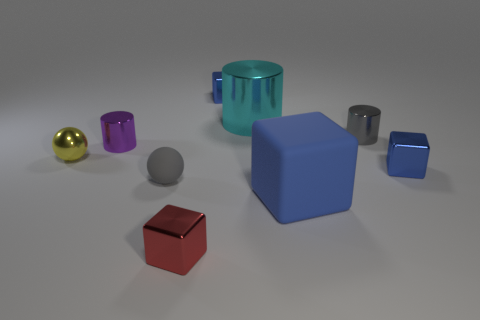There is a metal cube that is left of the gray metallic object and in front of the big metallic thing; what is its color?
Offer a terse response. Red. What number of cubes are small red objects or large purple shiny objects?
Give a very brief answer. 1. There is a blue rubber thing; is its shape the same as the tiny metallic object that is on the left side of the purple cylinder?
Give a very brief answer. No. What is the size of the block that is both left of the big matte thing and behind the red cube?
Keep it short and to the point. Small. There is a small gray metallic object; what shape is it?
Your answer should be very brief. Cylinder. Is there a yellow shiny ball to the left of the gray cylinder that is behind the yellow shiny thing?
Ensure brevity in your answer.  Yes. There is a tiny blue thing that is behind the small yellow shiny ball; how many metal things are right of it?
Offer a very short reply. 3. What is the material of the gray ball that is the same size as the red metal block?
Your response must be concise. Rubber. Do the blue object that is in front of the small gray rubber sphere and the red object have the same shape?
Give a very brief answer. Yes. Are there more red metallic cubes in front of the tiny red object than small red objects that are behind the big blue rubber object?
Offer a terse response. No. 